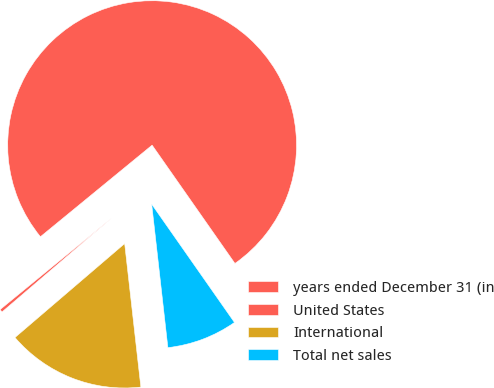Convert chart to OTSL. <chart><loc_0><loc_0><loc_500><loc_500><pie_chart><fcel>years ended December 31 (in<fcel>United States<fcel>International<fcel>Total net sales<nl><fcel>76.22%<fcel>0.34%<fcel>15.52%<fcel>7.93%<nl></chart> 